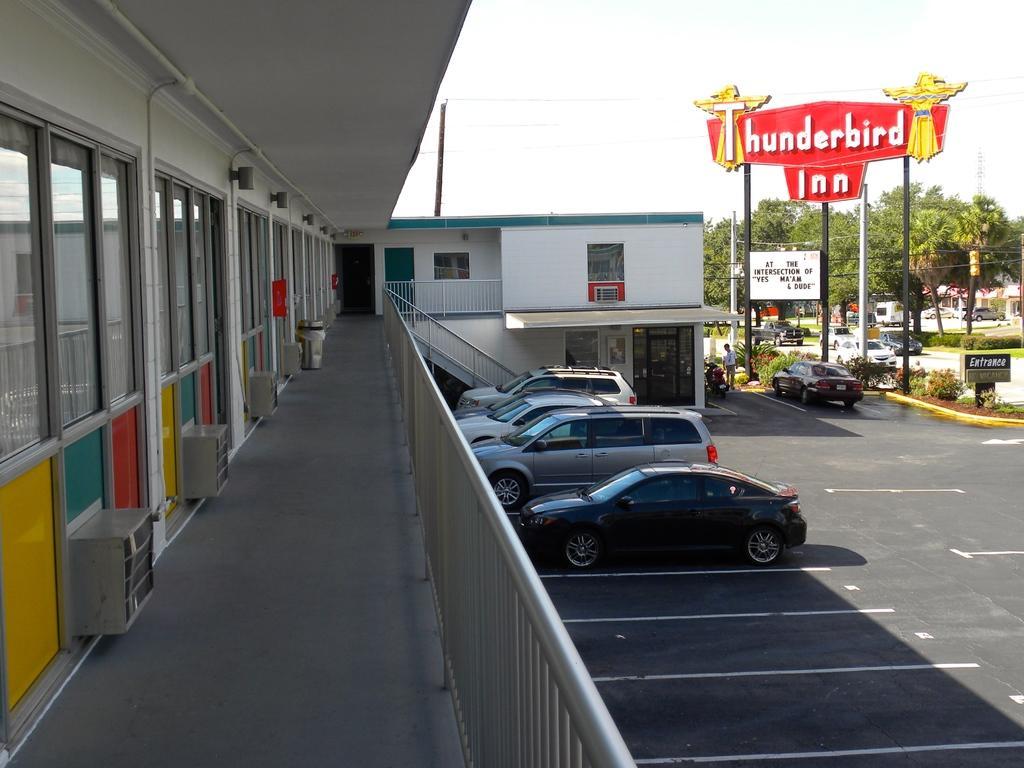Could you give a brief overview of what you see in this image? In this image we can see buildings, staircase, railings, motor vehicles in the parking slots and on the road, persons standing on the floor, name boards, trees, bushes, towers and sky. 